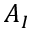Convert formula to latex. <formula><loc_0><loc_0><loc_500><loc_500>A _ { I }</formula> 